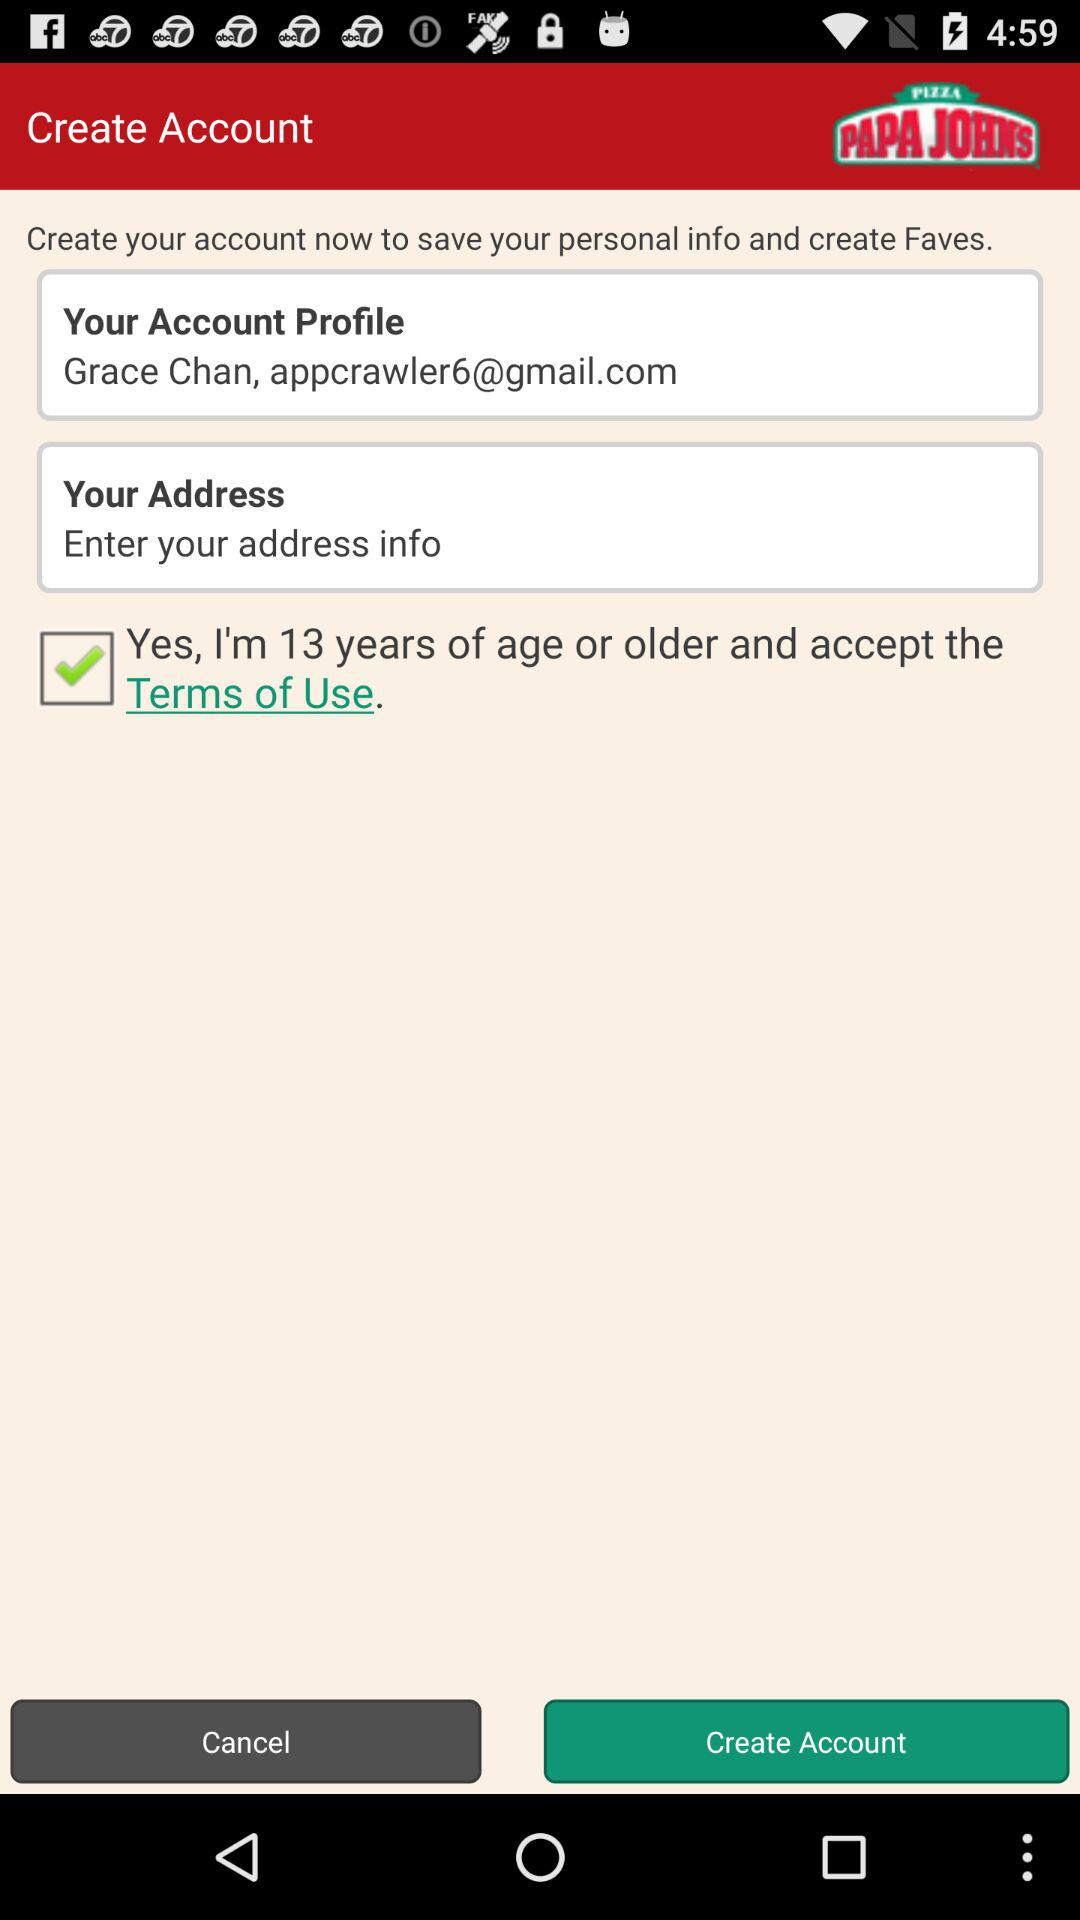What is the user name? The user name is Grace Chan. 